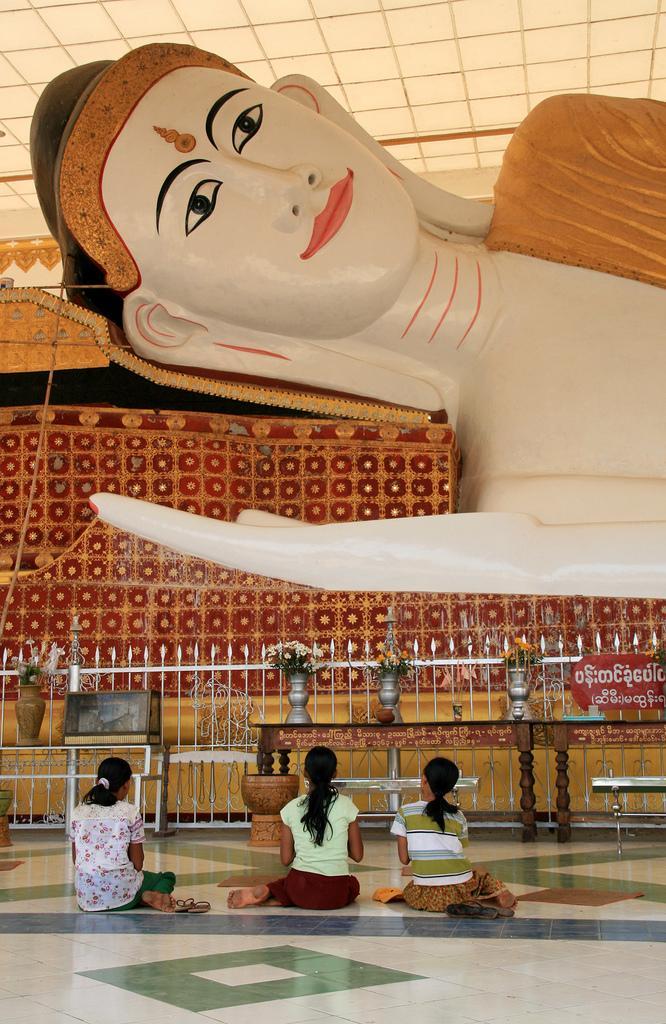Can you describe this image briefly? In this image I can see there are three girls sitting on the floor and I can see statue of lord and I can see a colorful cloth kept beside the statue and I can see a table , on the table I can see flower pots and the table is kept in the middle. 